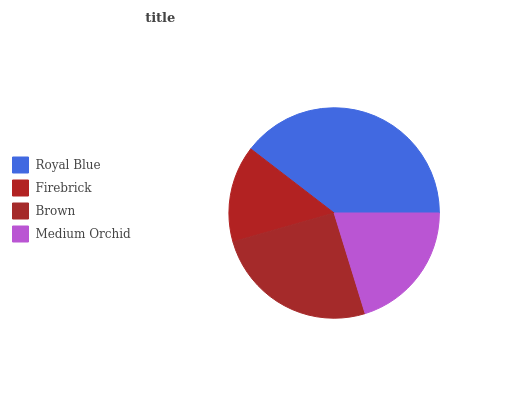Is Firebrick the minimum?
Answer yes or no. Yes. Is Royal Blue the maximum?
Answer yes or no. Yes. Is Brown the minimum?
Answer yes or no. No. Is Brown the maximum?
Answer yes or no. No. Is Brown greater than Firebrick?
Answer yes or no. Yes. Is Firebrick less than Brown?
Answer yes or no. Yes. Is Firebrick greater than Brown?
Answer yes or no. No. Is Brown less than Firebrick?
Answer yes or no. No. Is Brown the high median?
Answer yes or no. Yes. Is Medium Orchid the low median?
Answer yes or no. Yes. Is Medium Orchid the high median?
Answer yes or no. No. Is Royal Blue the low median?
Answer yes or no. No. 